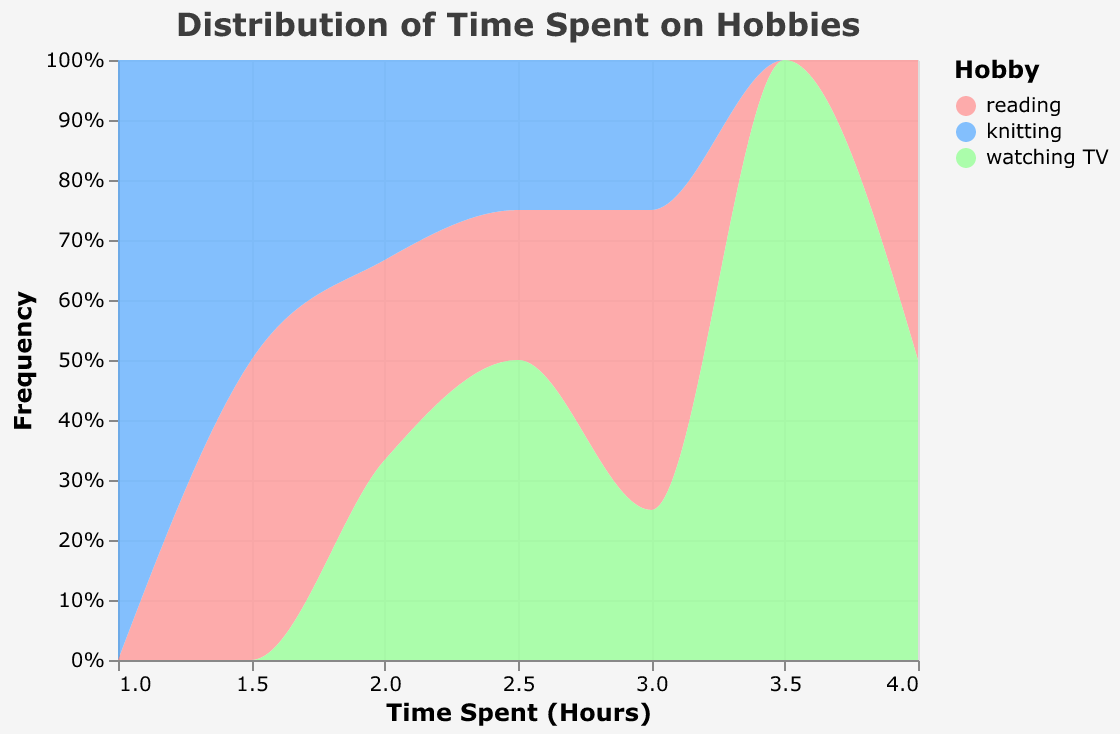What is the title of the figure? The title is usually placed at the top of the figure and indicates the subject of the displayed data. In this case, it tells us what the plot is about.
Answer: Distribution of Time Spent on Hobbies What does the x-axis represent? The x-axis typically shows the range of values for one of the variables being analyzed. Here, it indicates the amount of time spent in hours.
Answer: Time Spent (Hours) What does the y-axis represent? The y-axis often shows the frequency or count of occurrences. In this case, it shows the proportion of time spent on different hobbies, aggregated and normalized to a percentage.
Answer: Frequency (%) Which hobby has the highest color intensity in the plot? By examining the color scale and the areas corresponding to each hobby, we can see which hobby is represented most frequently at higher intensities.
Answer: Reading What is the time range in which "knitting" appears most frequently? We look for the regions where the color corresponding to "knitting" is most prominent on the x-axis.
Answer: 1.5 to 3 hours Which hobby is least frequent at the 3-hour mark? We compare the proportions of different hobbies at the 3-hour mark by looking at the respective areas under the curve on the plot.
Answer: Knitting How does the proportion of "watching TV" compare to "reading" at 4 hours? Compare the relative areas of the colors corresponding to watching TV and reading at the 4-hour mark. Reading is the most frequent hobby at this mark.
Answer: Watching TV is less frequent than reading What is the average range of time spent on hobbies? Examine the distribution of all hobbies along the x-axis and estimate an average range where most time is spent. Most of the time spent is between 1 to 4 hours.
Answer: 1 to 4 hours Which day shows the maximum total time spent reading? Sum the reading times for each day and identify the day with the highest sum.
Answer: Saturday Is there a trend in the data that shows any particular hobby being favored as the week progresses? By analyzing the density and distribution of the colors corresponding to each hobby across time, we can infer if people tend to spend more or less time on certain hobbies as the week progresses.
Answer: Reading time increases towards the weekend 